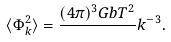Convert formula to latex. <formula><loc_0><loc_0><loc_500><loc_500>\langle \Phi _ { k } ^ { 2 } \rangle = \frac { ( 4 \pi ) ^ { 3 } G b T ^ { 2 } } { } k ^ { - 3 } .</formula> 